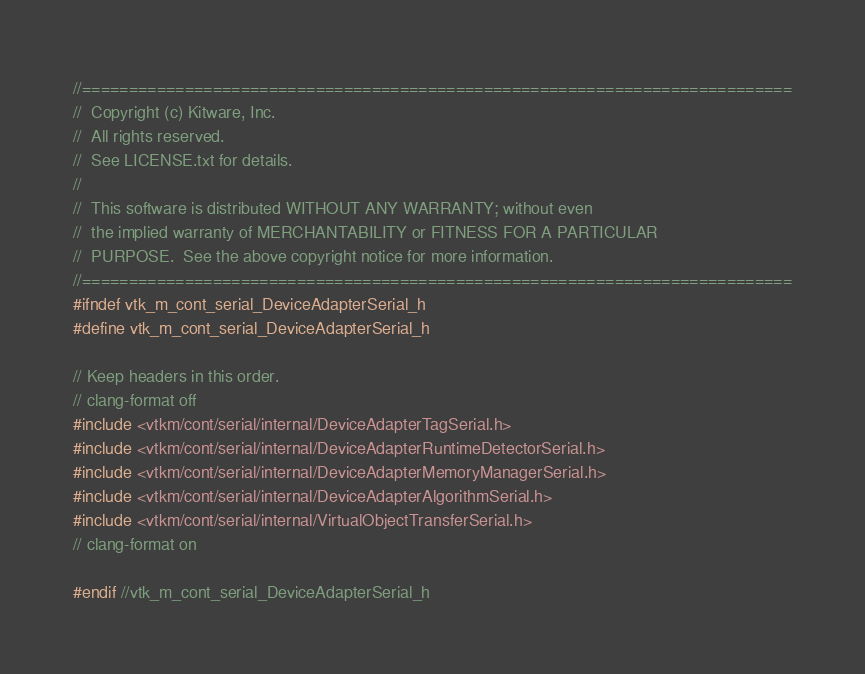<code> <loc_0><loc_0><loc_500><loc_500><_C_>//============================================================================
//  Copyright (c) Kitware, Inc.
//  All rights reserved.
//  See LICENSE.txt for details.
//
//  This software is distributed WITHOUT ANY WARRANTY; without even
//  the implied warranty of MERCHANTABILITY or FITNESS FOR A PARTICULAR
//  PURPOSE.  See the above copyright notice for more information.
//============================================================================
#ifndef vtk_m_cont_serial_DeviceAdapterSerial_h
#define vtk_m_cont_serial_DeviceAdapterSerial_h

// Keep headers in this order.
// clang-format off
#include <vtkm/cont/serial/internal/DeviceAdapterTagSerial.h>
#include <vtkm/cont/serial/internal/DeviceAdapterRuntimeDetectorSerial.h>
#include <vtkm/cont/serial/internal/DeviceAdapterMemoryManagerSerial.h>
#include <vtkm/cont/serial/internal/DeviceAdapterAlgorithmSerial.h>
#include <vtkm/cont/serial/internal/VirtualObjectTransferSerial.h>
// clang-format on

#endif //vtk_m_cont_serial_DeviceAdapterSerial_h
</code> 